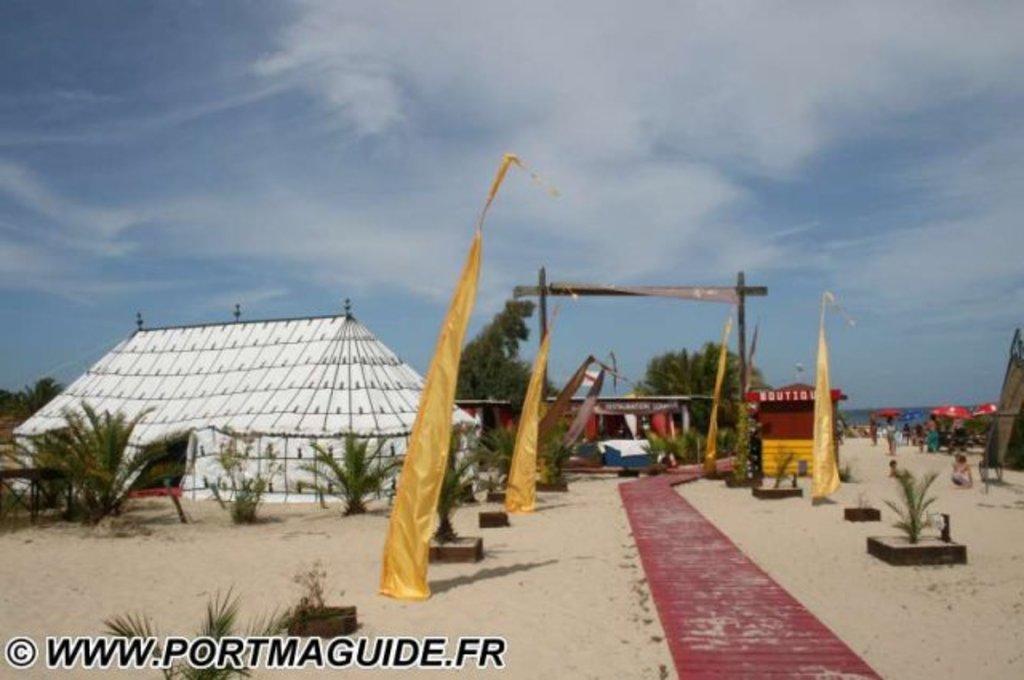Can you describe this image briefly? In this picture we can see few tents, trees, plants and group of people, in the background we can see few umbrellas and clouds, at the left bottom of the image we can see a watermark. 